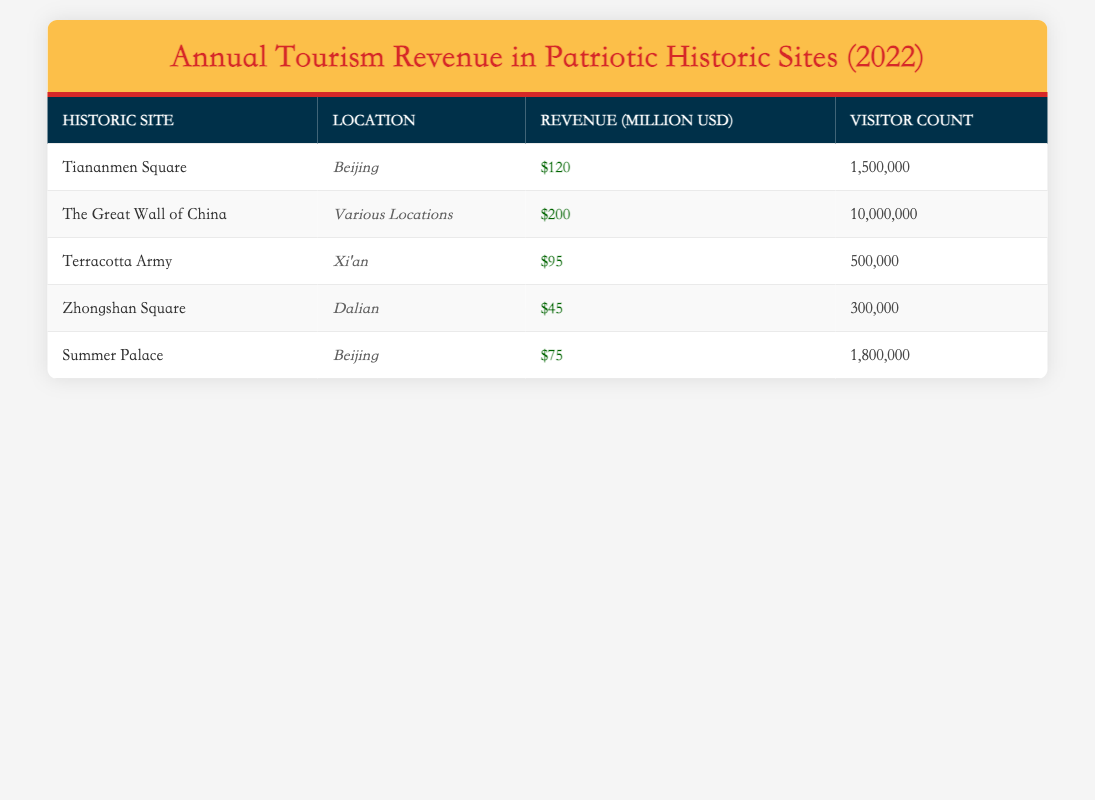What is the revenue generated by The Great Wall of China? The revenue for The Great Wall of China is listed in the table under the Revenue (Million USD) column. It states that the revenue is $200 million.
Answer: 200 million USD How many visitors did the Terracotta Army attract in 2022? The Visitor Count for the Terracotta Army is provided in the table. It shows that it attracted 500,000 visitors.
Answer: 500,000 visitors Which historic site generated the least revenue in 2022? To find the least revenue, we compare the Revenue (Million USD) values for all historic sites. Zhongshan Square has the lowest revenue of $45 million.
Answer: Zhongshan Square What is the total visitor count for all historic sites listed? To find the total visitor count, we sum the Visitor Count for each site: 1,500,000 + 10,000,000 + 500,000 + 300,000 + 1,800,000 = 14,100,000.
Answer: 14,100,000 visitors Was the revenue from the Summer Palace greater than or equal to the revenue from the Terracotta Army? The revenue for the Summer Palace is $75 million, and for the Terracotta Army, it is $95 million. Since $75 million is less than $95 million, the answer is no.
Answer: No Which historic site had a visitor count greater than 1,000,000? We examine the Visitor Count for each site. The Great Wall of China (10,000,000), Tiananmen Square (1,500,000), and Summer Palace (1,800,000) all have counts exceeding 1,000,000.
Answer: The Great Wall of China, Tiananmen Square, Summer Palace What is the average revenue of the historic sites in the table? To find the average, we sum the revenues: 120 + 200 + 95 + 45 + 75 = 535 million. There are 5 sites, so we divide by 5: 535 / 5 = 107 million.
Answer: 107 million USD Did the total revenue from sites located in Beijing exceed 300 million USD? The revenue from sites in Beijing are Tiananmen Square ($120 million) and Summer Palace ($75 million). Adding these gives $120 million + $75 million = $195 million, which does not exceed 300 million.
Answer: No What is the difference in visitor count between The Great Wall of China and Zhongshan Square? The Visitor Count for The Great Wall of China is 10,000,000 and for Zhongshan Square, it is 300,000. The difference is 10,000,000 - 300,000 = 9,700,000.
Answer: 9,700,000 visitors 